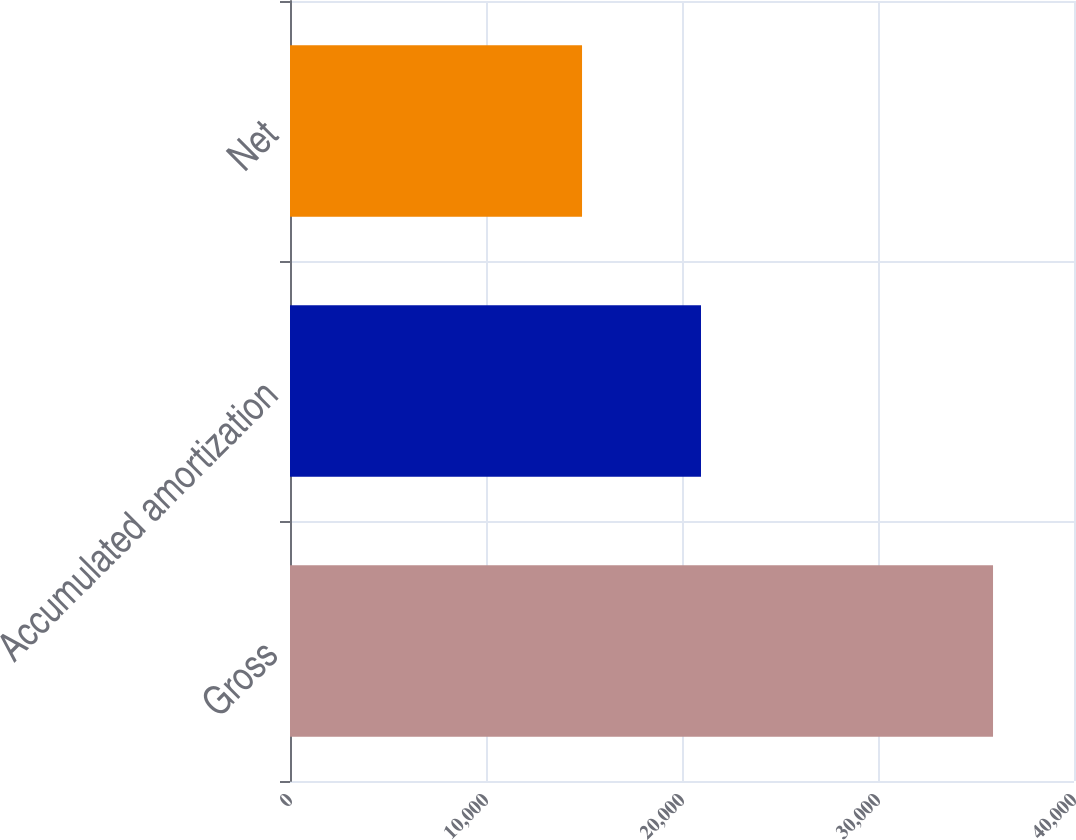Convert chart to OTSL. <chart><loc_0><loc_0><loc_500><loc_500><bar_chart><fcel>Gross<fcel>Accumulated amortization<fcel>Net<nl><fcel>35869<fcel>20969<fcel>14900<nl></chart> 